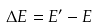<formula> <loc_0><loc_0><loc_500><loc_500>\Delta E = E ^ { \prime } - E</formula> 